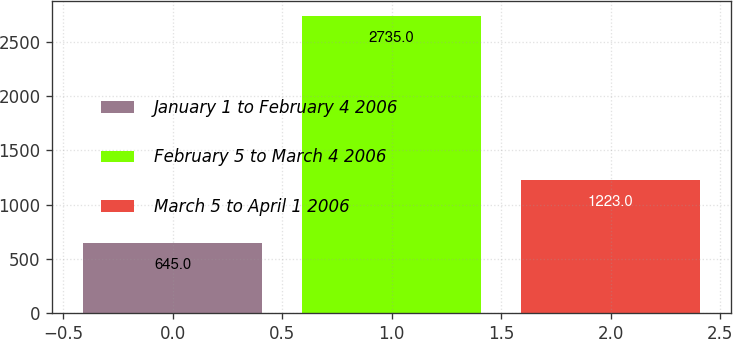<chart> <loc_0><loc_0><loc_500><loc_500><bar_chart><fcel>January 1 to February 4 2006<fcel>February 5 to March 4 2006<fcel>March 5 to April 1 2006<nl><fcel>645<fcel>2735<fcel>1223<nl></chart> 